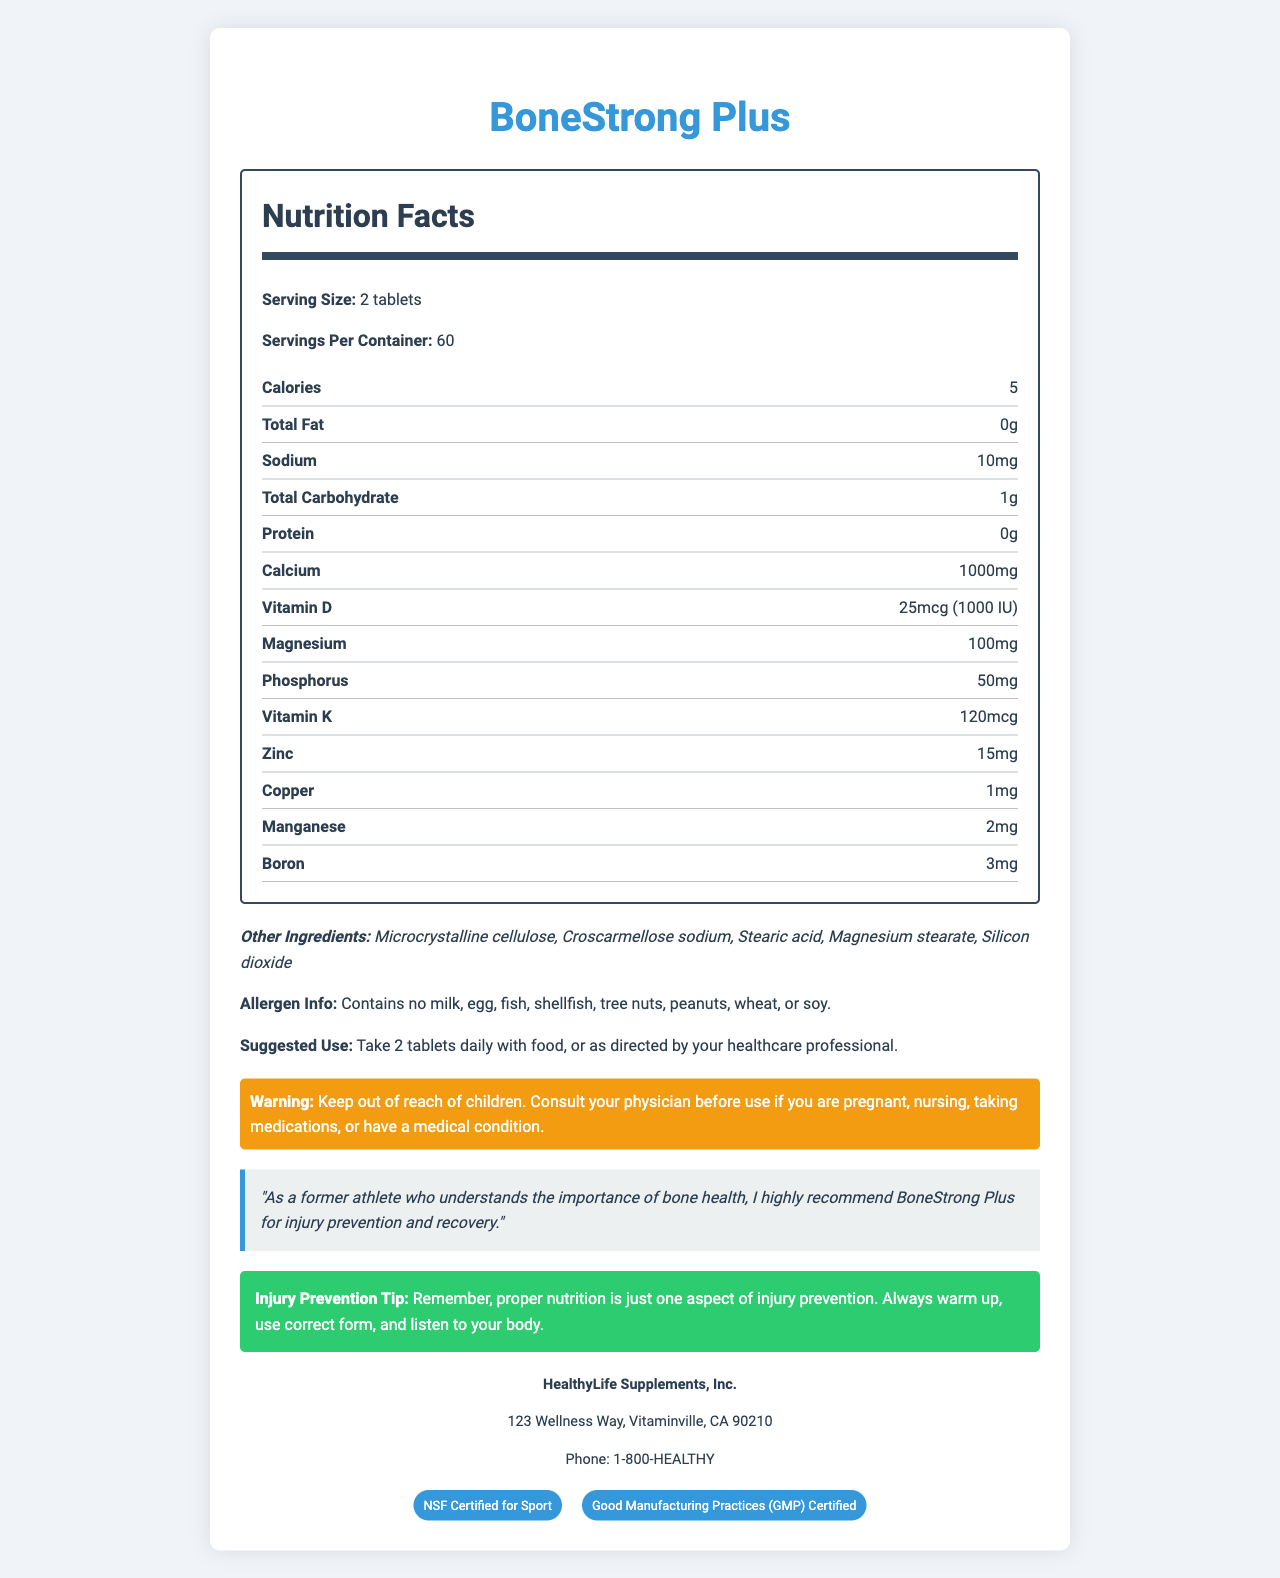what is the serving size for BoneStrong Plus? The serving size is explicitly mentioned in the document as "Serving Size: 2 tablets."
Answer: 2 tablets how many servings are in one container? The document states "Servings Per Container: 60."
Answer: 60 how many calories are in each serving? The document indicates "Calories: 5" under the nutrition information.
Answer: 5 what amount of calcium is provided per serving? The amount of calcium per serving is listed as "Calcium: 1000mg."
Answer: 1000mg how much vitamin D does each serving contain? According to the document, each serving provides "Vitamin D: 25mcg (1000 IU)."
Answer: 25mcg (1000 IU) what is the suggested use for this supplement? The document states the suggested use as "Take 2 tablets daily with food, or as directed by your healthcare professional."
Answer: Take 2 tablets daily with food, or as directed by your healthcare professional which of the following ingredients is not found in BoneStrong Plus? A. Croscarmellose sodium B. Silicon dioxide C. Sucrose D. Stearic acid The document lists "Microcrystalline cellulose, Croscarmellose sodium, Stearic acid, Magnesium stearate, Silicon dioxide" as other ingredients. Sucrose is not mentioned.
Answer: C what is the sodium content per serving? The sodium content per serving is given as "Sodium: 10mg."
Answer: 10mg does the product contain any major allergens such as milk, egg, or soy? The allergen info states "Contains no milk, egg, fish, shellfish, tree nuts, peanuts, wheat, or soy."
Answer: No what is a tip provided in the document for injury prevention? A. Exercise daily B. Avoid all physical activity C. Proper nutrition is just one aspect of injury prevention. Always warm up, use correct form, and listen to your body D. Skip meals to lose weight The document explicitly offers the injury prevention tip mentioned in option C.
Answer: C what certifications does BoneStrong Plus have? The certifications are listed in the document as "NSF Certified for Sport" and "Good Manufacturing Practices (GMP) Certified."
Answer: NSF Certified for Sport, Good Manufacturing Practices (GMP) Certified who manufactures BoneStrong Plus? A. Wellness Corp B. Bone Health Supplements LLC C. HealthyLife Supplements, Inc. D. Vitamin Health Inc. The manufacturer info states "HealthyLife Supplements, Inc."
Answer: C is the product recommended for pregnant or nursing women without consulting a physician? The warning statement advises consulting a physician if pregnant, nursing, taking medications, or having a medical condition.
Answer: No can we determine the price of BoneStrong Plus from this document? The document does not provide any information regarding the price of BoneStrong Plus.
Answer: Not enough information summarize the main idea of the document. The document outlines the nutritional content, usage instructions, allergen information, manufacturer details, and certifications of the BoneStrong Plus supplement, emphasizing its benefits for bone health and injury prevention.
Answer: BoneStrong Plus is a calcium and vitamin D-rich supplement designed to support bone health and injury prevention. It provides important nutrients like calcium, vitamin D, magnesium, and more. The product is free from major allergens, and the suggested use is to take 2 tablets daily with food. It is certified for sport and manufactured by HealthyLife Supplements, Inc. The document also includes a testimonial from a former athlete and a tip for injury prevention. 